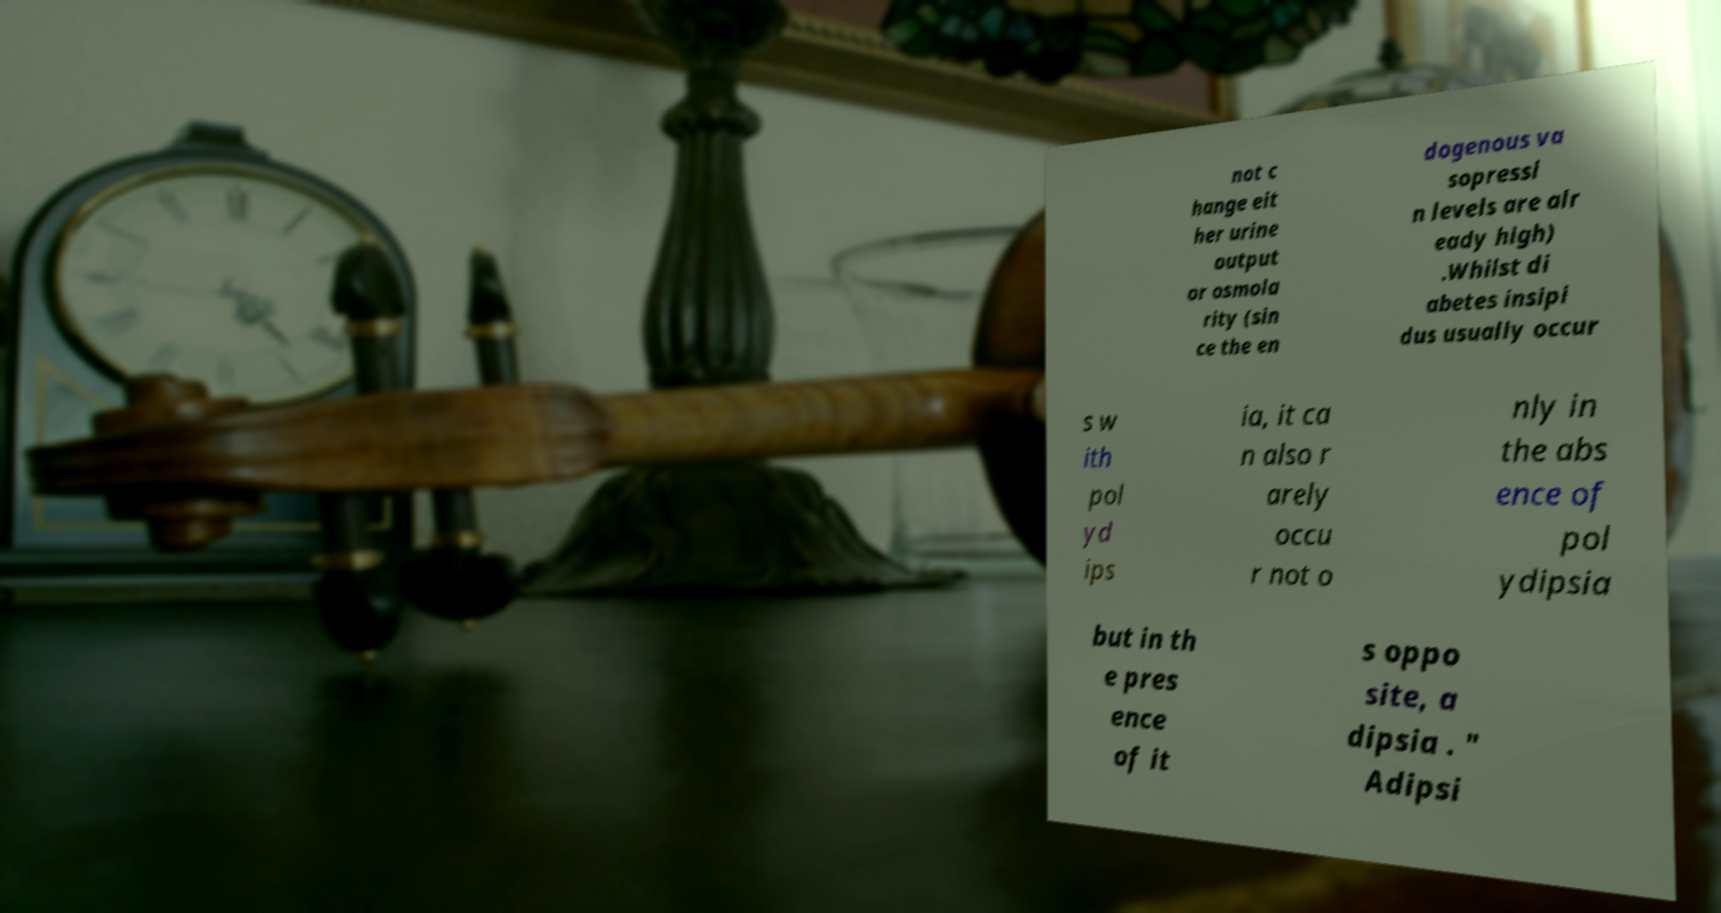Please read and relay the text visible in this image. What does it say? not c hange eit her urine output or osmola rity (sin ce the en dogenous va sopressi n levels are alr eady high) .Whilst di abetes insipi dus usually occur s w ith pol yd ips ia, it ca n also r arely occu r not o nly in the abs ence of pol ydipsia but in th e pres ence of it s oppo site, a dipsia . " Adipsi 